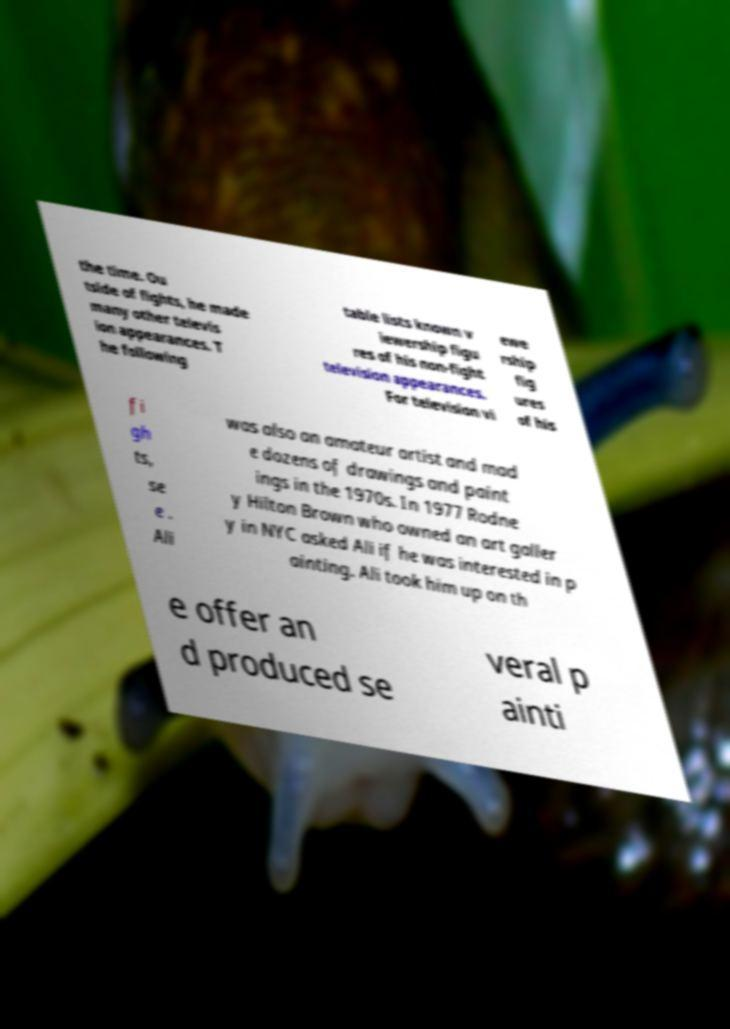Please identify and transcribe the text found in this image. the time. Ou tside of fights, he made many other televis ion appearances. T he following table lists known v iewership figu res of his non-fight television appearances. For television vi ewe rship fig ures of his fi gh ts, se e . Ali was also an amateur artist and mad e dozens of drawings and paint ings in the 1970s. In 1977 Rodne y Hilton Brown who owned an art galler y in NYC asked Ali if he was interested in p ainting. Ali took him up on th e offer an d produced se veral p ainti 